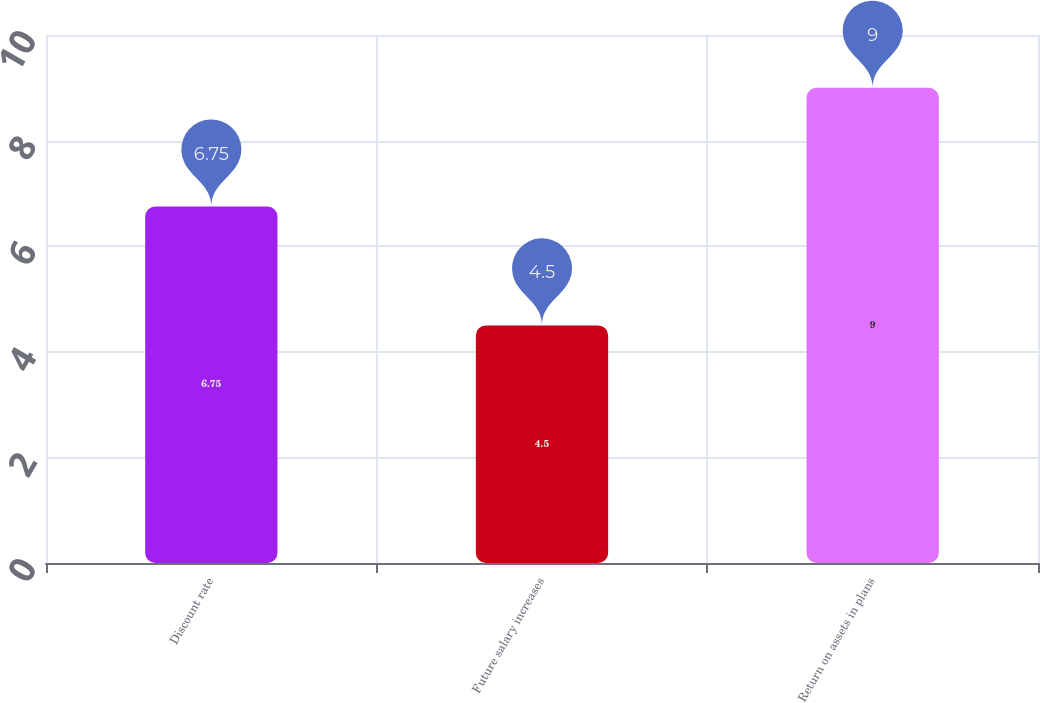<chart> <loc_0><loc_0><loc_500><loc_500><bar_chart><fcel>Discount rate<fcel>Future salary increases<fcel>Return on assets in plans<nl><fcel>6.75<fcel>4.5<fcel>9<nl></chart> 